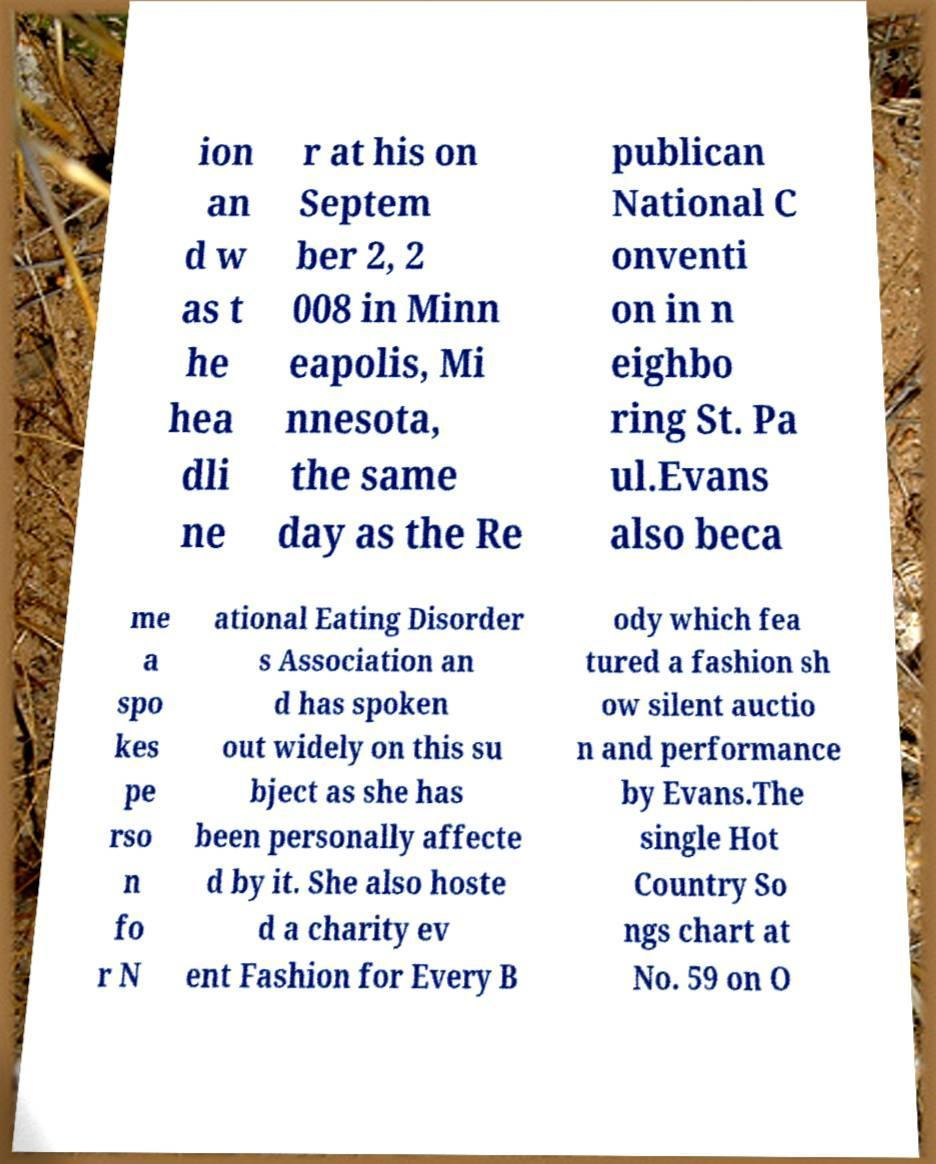Could you extract and type out the text from this image? ion an d w as t he hea dli ne r at his on Septem ber 2, 2 008 in Minn eapolis, Mi nnesota, the same day as the Re publican National C onventi on in n eighbo ring St. Pa ul.Evans also beca me a spo kes pe rso n fo r N ational Eating Disorder s Association an d has spoken out widely on this su bject as she has been personally affecte d by it. She also hoste d a charity ev ent Fashion for Every B ody which fea tured a fashion sh ow silent auctio n and performance by Evans.The single Hot Country So ngs chart at No. 59 on O 